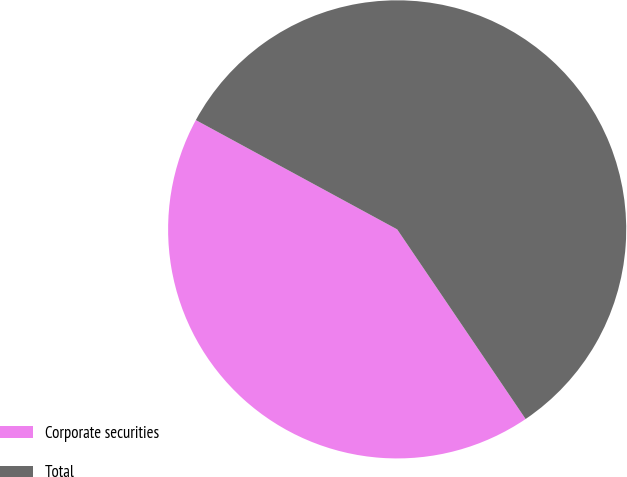<chart> <loc_0><loc_0><loc_500><loc_500><pie_chart><fcel>Corporate securities<fcel>Total<nl><fcel>42.39%<fcel>57.61%<nl></chart> 